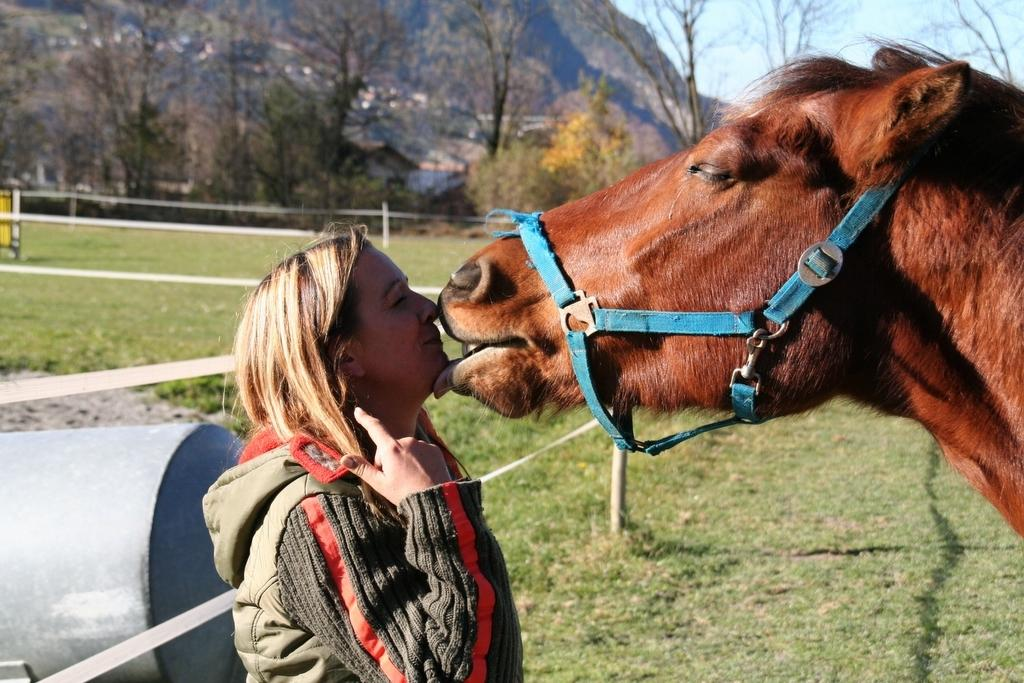Who is present in the image? There is a woman in the image. What is the woman doing in the image? The woman is standing in front of a horse. What type of terrain is visible in the image? There is grass in the image. What can be seen in the distance in the image? There are trees and a mountain in the background of the image. What part of the natural environment is visible in the image? The sky is visible in the image. How many kittens are sitting on the woman's shoulder in the image? There are no kittens present in the image. 